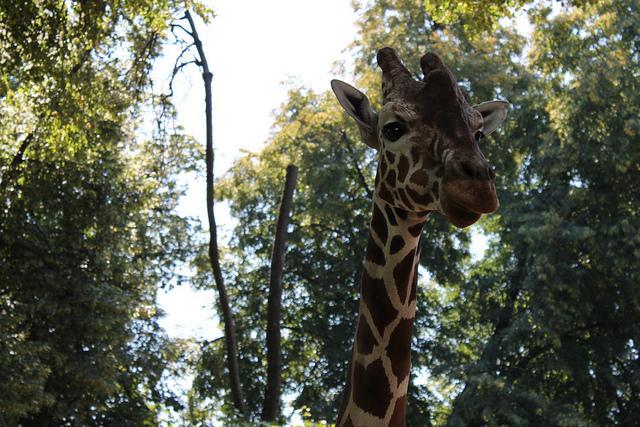How many giraffes are pictured?
Answer briefly. 1. Is the giraffe facing the camera?
Keep it brief. Yes. Would this giraffe be young or old?
Answer briefly. Old. 